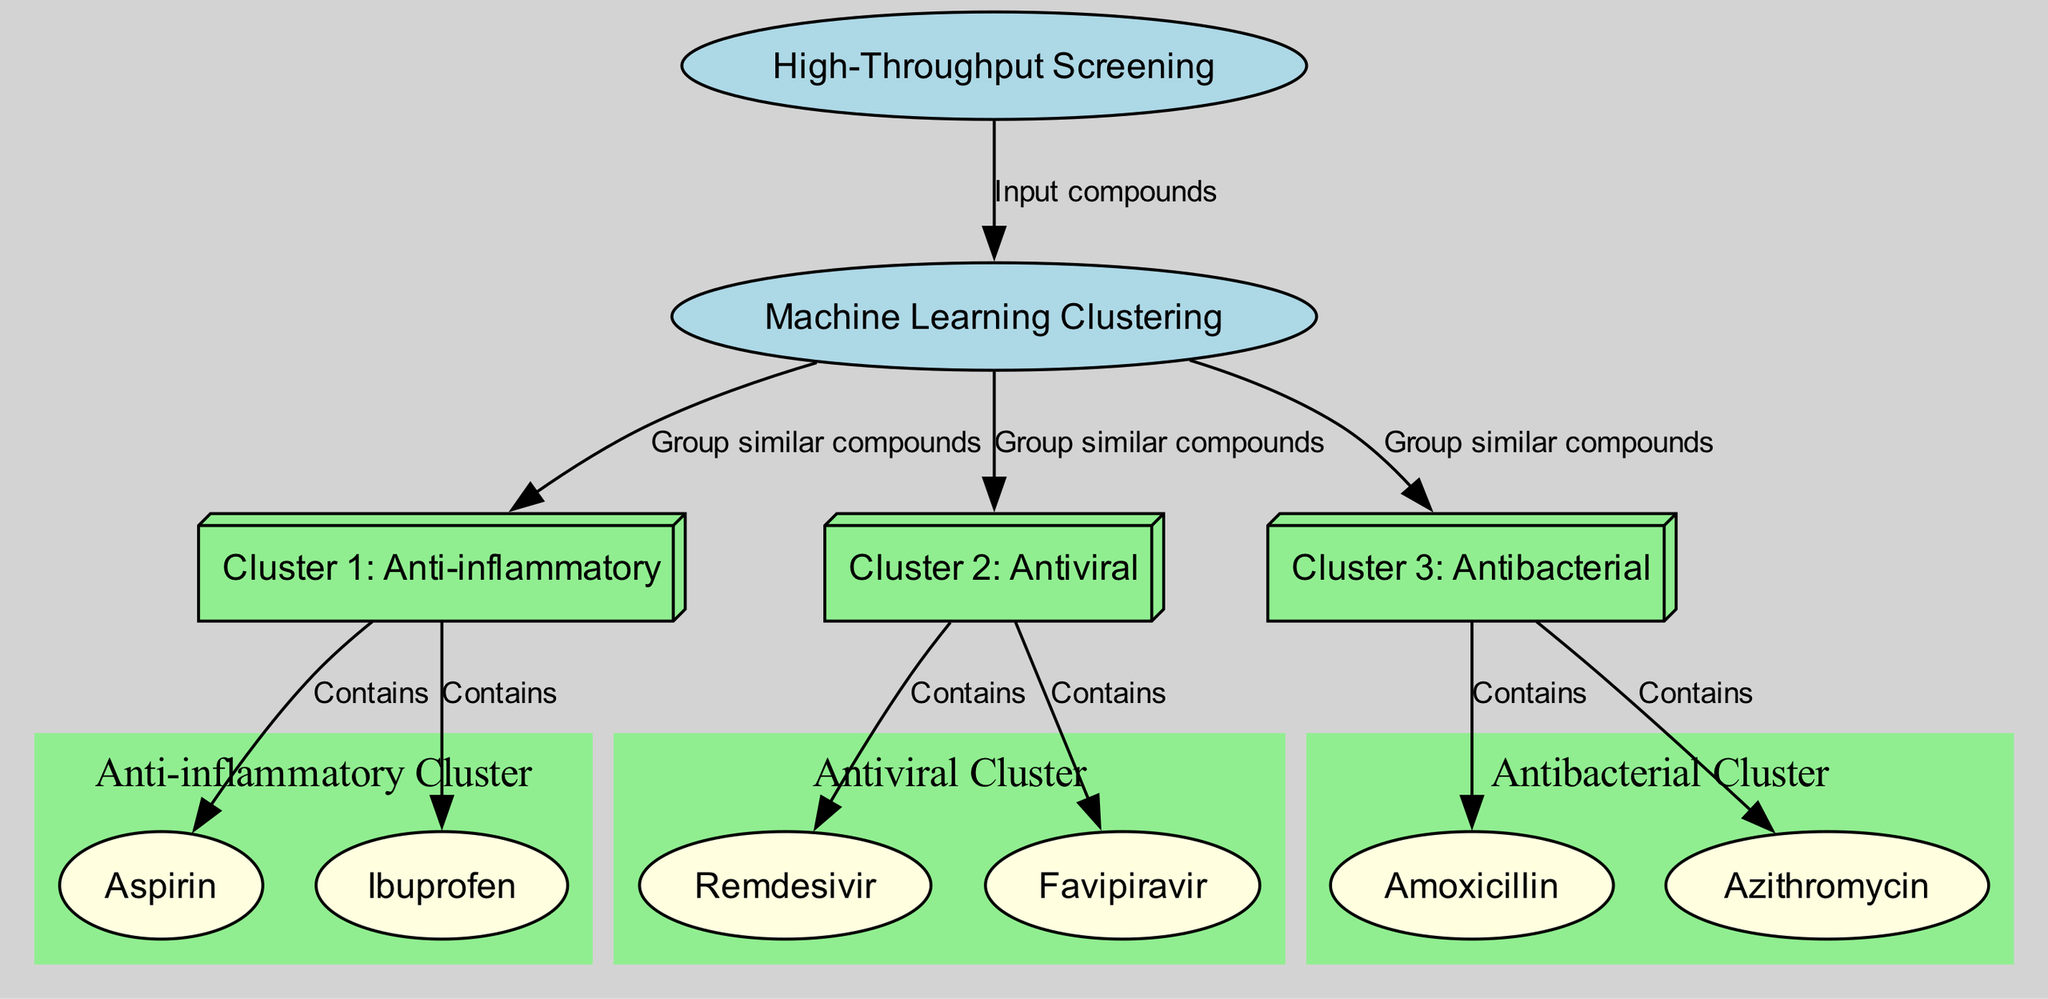What is the primary process represented in the diagram? The diagram emphasizes the process of high-throughput screening, identified as the initial node labeled "High-Throughput Screening".
Answer: High-Throughput Screening How many clusters are shown in the diagram? There are three distinct clusters depicted in the diagram, labeled "Cluster 1: Anti-inflammatory", "Cluster 2: Antiviral", and "Cluster 3: Antibacterial".
Answer: Three Which machine learning process groups similar compounds? The machine learning process is indicated by the node labeled "Machine Learning Clustering", which connects to the clusters, demonstrating its role in grouping similar compounds.
Answer: Machine Learning Clustering What compounds are included in Cluster 3? Cluster 3, known as the "Antibacterial Cluster", contains the compounds "Amoxicillin" and "Azithromycin", directly linked to Cluster 3 within the diagram.
Answer: Amoxicillin and Azithromycin Which clusters contain antiviral compounds? Only "Cluster 2: Antiviral" contains the compounds related to antiviral properties, specifically "Remdesivir" and "Favipiravir", as indicated in the edges leading to this cluster.
Answer: Cluster 2: Antiviral How many edges connect the machine learning process to the clusters? The machine learning process connects to all three clusters through three distinct edges, each labeled as "Group similar compounds" indicating the action taken for each cluster.
Answer: Three Which compound is shared between Cluster 1 and Cluster 2? No compounds are indicated as being shared between Cluster 1 and Cluster 2, as each cluster contains distinct compounds as per the connections in the diagram.
Answer: None What type of diagram is used to represent compound relationships? The diagram is a clustering diagram that illustrates how machine learning organizes compounds according to similarities in their chemical properties for high-throughput screening purposes.
Answer: Clustering diagram What color represents the compounds in the diagram? The compounds are represented by the color light yellow in the diagram, distinctly differentiating them from the clusters and processes which use other colors.
Answer: Light yellow 